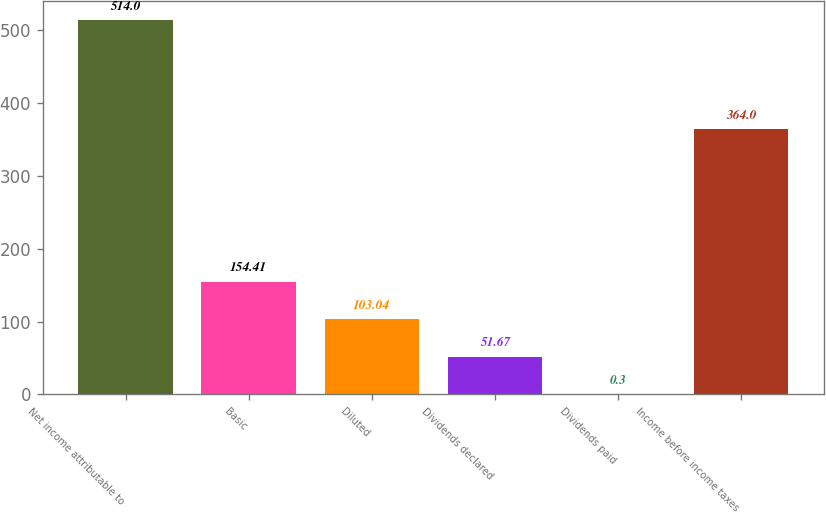<chart> <loc_0><loc_0><loc_500><loc_500><bar_chart><fcel>Net income attributable to<fcel>Basic<fcel>Diluted<fcel>Dividends declared<fcel>Dividends paid<fcel>Income before income taxes<nl><fcel>514<fcel>154.41<fcel>103.04<fcel>51.67<fcel>0.3<fcel>364<nl></chart> 